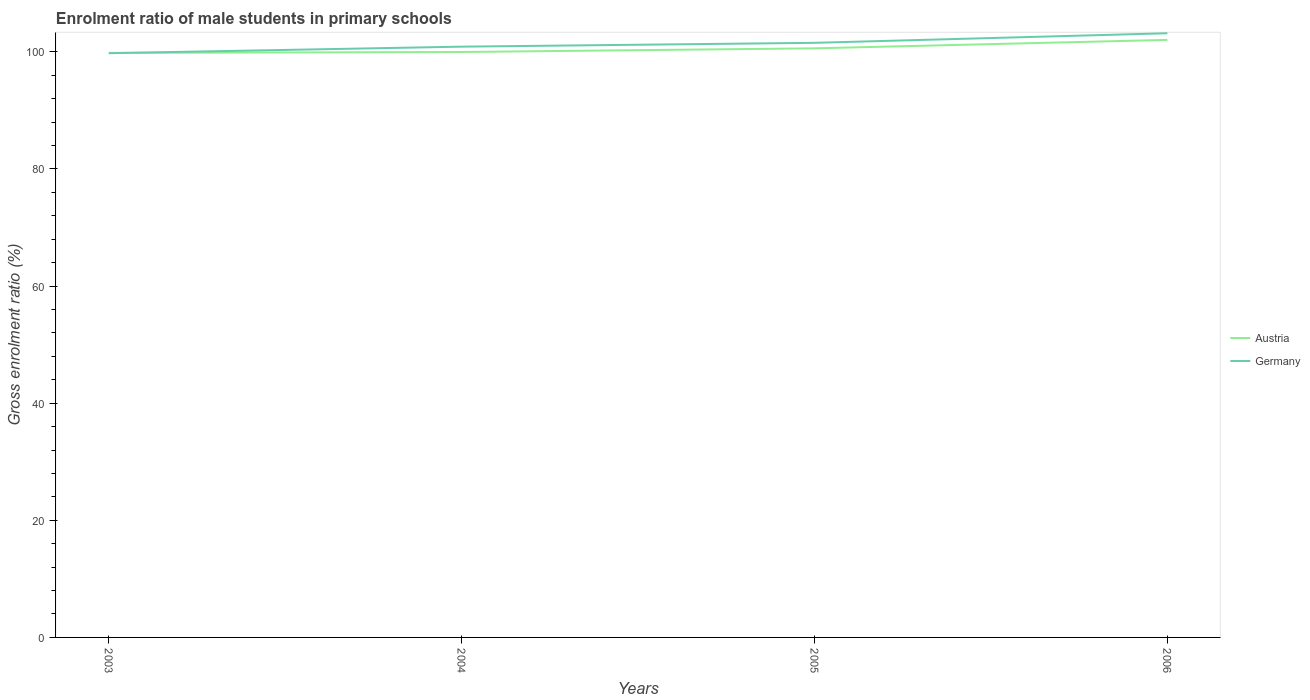How many different coloured lines are there?
Your answer should be compact. 2. Does the line corresponding to Germany intersect with the line corresponding to Austria?
Offer a terse response. Yes. Is the number of lines equal to the number of legend labels?
Ensure brevity in your answer.  Yes. Across all years, what is the maximum enrolment ratio of male students in primary schools in Austria?
Offer a very short reply. 99.81. In which year was the enrolment ratio of male students in primary schools in Germany maximum?
Your answer should be very brief. 2003. What is the total enrolment ratio of male students in primary schools in Germany in the graph?
Your answer should be compact. -3.41. What is the difference between the highest and the second highest enrolment ratio of male students in primary schools in Austria?
Provide a succinct answer. 2.22. What is the difference between the highest and the lowest enrolment ratio of male students in primary schools in Germany?
Your answer should be compact. 2. Is the enrolment ratio of male students in primary schools in Germany strictly greater than the enrolment ratio of male students in primary schools in Austria over the years?
Give a very brief answer. No. How many lines are there?
Your answer should be very brief. 2. Does the graph contain any zero values?
Make the answer very short. No. Does the graph contain grids?
Provide a succinct answer. No. Where does the legend appear in the graph?
Offer a very short reply. Center right. What is the title of the graph?
Your answer should be compact. Enrolment ratio of male students in primary schools. What is the label or title of the X-axis?
Provide a short and direct response. Years. What is the Gross enrolment ratio (%) of Austria in 2003?
Keep it short and to the point. 99.81. What is the Gross enrolment ratio (%) of Germany in 2003?
Offer a very short reply. 99.75. What is the Gross enrolment ratio (%) of Austria in 2004?
Ensure brevity in your answer.  99.96. What is the Gross enrolment ratio (%) of Germany in 2004?
Provide a succinct answer. 100.87. What is the Gross enrolment ratio (%) of Austria in 2005?
Ensure brevity in your answer.  100.58. What is the Gross enrolment ratio (%) of Germany in 2005?
Make the answer very short. 101.52. What is the Gross enrolment ratio (%) in Austria in 2006?
Make the answer very short. 102.02. What is the Gross enrolment ratio (%) in Germany in 2006?
Your answer should be very brief. 103.16. Across all years, what is the maximum Gross enrolment ratio (%) in Austria?
Offer a very short reply. 102.02. Across all years, what is the maximum Gross enrolment ratio (%) in Germany?
Make the answer very short. 103.16. Across all years, what is the minimum Gross enrolment ratio (%) in Austria?
Give a very brief answer. 99.81. Across all years, what is the minimum Gross enrolment ratio (%) of Germany?
Offer a terse response. 99.75. What is the total Gross enrolment ratio (%) in Austria in the graph?
Offer a very short reply. 402.37. What is the total Gross enrolment ratio (%) in Germany in the graph?
Provide a short and direct response. 405.3. What is the difference between the Gross enrolment ratio (%) of Austria in 2003 and that in 2004?
Make the answer very short. -0.15. What is the difference between the Gross enrolment ratio (%) of Germany in 2003 and that in 2004?
Give a very brief answer. -1.12. What is the difference between the Gross enrolment ratio (%) in Austria in 2003 and that in 2005?
Your response must be concise. -0.78. What is the difference between the Gross enrolment ratio (%) of Germany in 2003 and that in 2005?
Provide a short and direct response. -1.77. What is the difference between the Gross enrolment ratio (%) in Austria in 2003 and that in 2006?
Your answer should be very brief. -2.22. What is the difference between the Gross enrolment ratio (%) in Germany in 2003 and that in 2006?
Offer a terse response. -3.41. What is the difference between the Gross enrolment ratio (%) of Austria in 2004 and that in 2005?
Provide a succinct answer. -0.63. What is the difference between the Gross enrolment ratio (%) of Germany in 2004 and that in 2005?
Make the answer very short. -0.65. What is the difference between the Gross enrolment ratio (%) of Austria in 2004 and that in 2006?
Your answer should be very brief. -2.07. What is the difference between the Gross enrolment ratio (%) in Germany in 2004 and that in 2006?
Ensure brevity in your answer.  -2.29. What is the difference between the Gross enrolment ratio (%) of Austria in 2005 and that in 2006?
Offer a very short reply. -1.44. What is the difference between the Gross enrolment ratio (%) in Germany in 2005 and that in 2006?
Ensure brevity in your answer.  -1.64. What is the difference between the Gross enrolment ratio (%) in Austria in 2003 and the Gross enrolment ratio (%) in Germany in 2004?
Provide a short and direct response. -1.06. What is the difference between the Gross enrolment ratio (%) of Austria in 2003 and the Gross enrolment ratio (%) of Germany in 2005?
Your response must be concise. -1.72. What is the difference between the Gross enrolment ratio (%) in Austria in 2003 and the Gross enrolment ratio (%) in Germany in 2006?
Provide a succinct answer. -3.35. What is the difference between the Gross enrolment ratio (%) in Austria in 2004 and the Gross enrolment ratio (%) in Germany in 2005?
Keep it short and to the point. -1.57. What is the difference between the Gross enrolment ratio (%) of Austria in 2004 and the Gross enrolment ratio (%) of Germany in 2006?
Your answer should be compact. -3.2. What is the difference between the Gross enrolment ratio (%) in Austria in 2005 and the Gross enrolment ratio (%) in Germany in 2006?
Provide a short and direct response. -2.58. What is the average Gross enrolment ratio (%) of Austria per year?
Offer a very short reply. 100.59. What is the average Gross enrolment ratio (%) in Germany per year?
Your response must be concise. 101.33. In the year 2003, what is the difference between the Gross enrolment ratio (%) of Austria and Gross enrolment ratio (%) of Germany?
Make the answer very short. 0.05. In the year 2004, what is the difference between the Gross enrolment ratio (%) in Austria and Gross enrolment ratio (%) in Germany?
Offer a terse response. -0.91. In the year 2005, what is the difference between the Gross enrolment ratio (%) in Austria and Gross enrolment ratio (%) in Germany?
Ensure brevity in your answer.  -0.94. In the year 2006, what is the difference between the Gross enrolment ratio (%) of Austria and Gross enrolment ratio (%) of Germany?
Make the answer very short. -1.13. What is the ratio of the Gross enrolment ratio (%) in Germany in 2003 to that in 2004?
Ensure brevity in your answer.  0.99. What is the ratio of the Gross enrolment ratio (%) of Germany in 2003 to that in 2005?
Provide a short and direct response. 0.98. What is the ratio of the Gross enrolment ratio (%) of Austria in 2003 to that in 2006?
Give a very brief answer. 0.98. What is the ratio of the Gross enrolment ratio (%) in Germany in 2003 to that in 2006?
Your answer should be very brief. 0.97. What is the ratio of the Gross enrolment ratio (%) of Austria in 2004 to that in 2005?
Ensure brevity in your answer.  0.99. What is the ratio of the Gross enrolment ratio (%) of Germany in 2004 to that in 2005?
Keep it short and to the point. 0.99. What is the ratio of the Gross enrolment ratio (%) in Austria in 2004 to that in 2006?
Your answer should be very brief. 0.98. What is the ratio of the Gross enrolment ratio (%) in Germany in 2004 to that in 2006?
Your answer should be very brief. 0.98. What is the ratio of the Gross enrolment ratio (%) in Austria in 2005 to that in 2006?
Your answer should be very brief. 0.99. What is the ratio of the Gross enrolment ratio (%) in Germany in 2005 to that in 2006?
Provide a succinct answer. 0.98. What is the difference between the highest and the second highest Gross enrolment ratio (%) of Austria?
Offer a terse response. 1.44. What is the difference between the highest and the second highest Gross enrolment ratio (%) in Germany?
Offer a terse response. 1.64. What is the difference between the highest and the lowest Gross enrolment ratio (%) in Austria?
Provide a short and direct response. 2.22. What is the difference between the highest and the lowest Gross enrolment ratio (%) in Germany?
Offer a terse response. 3.41. 